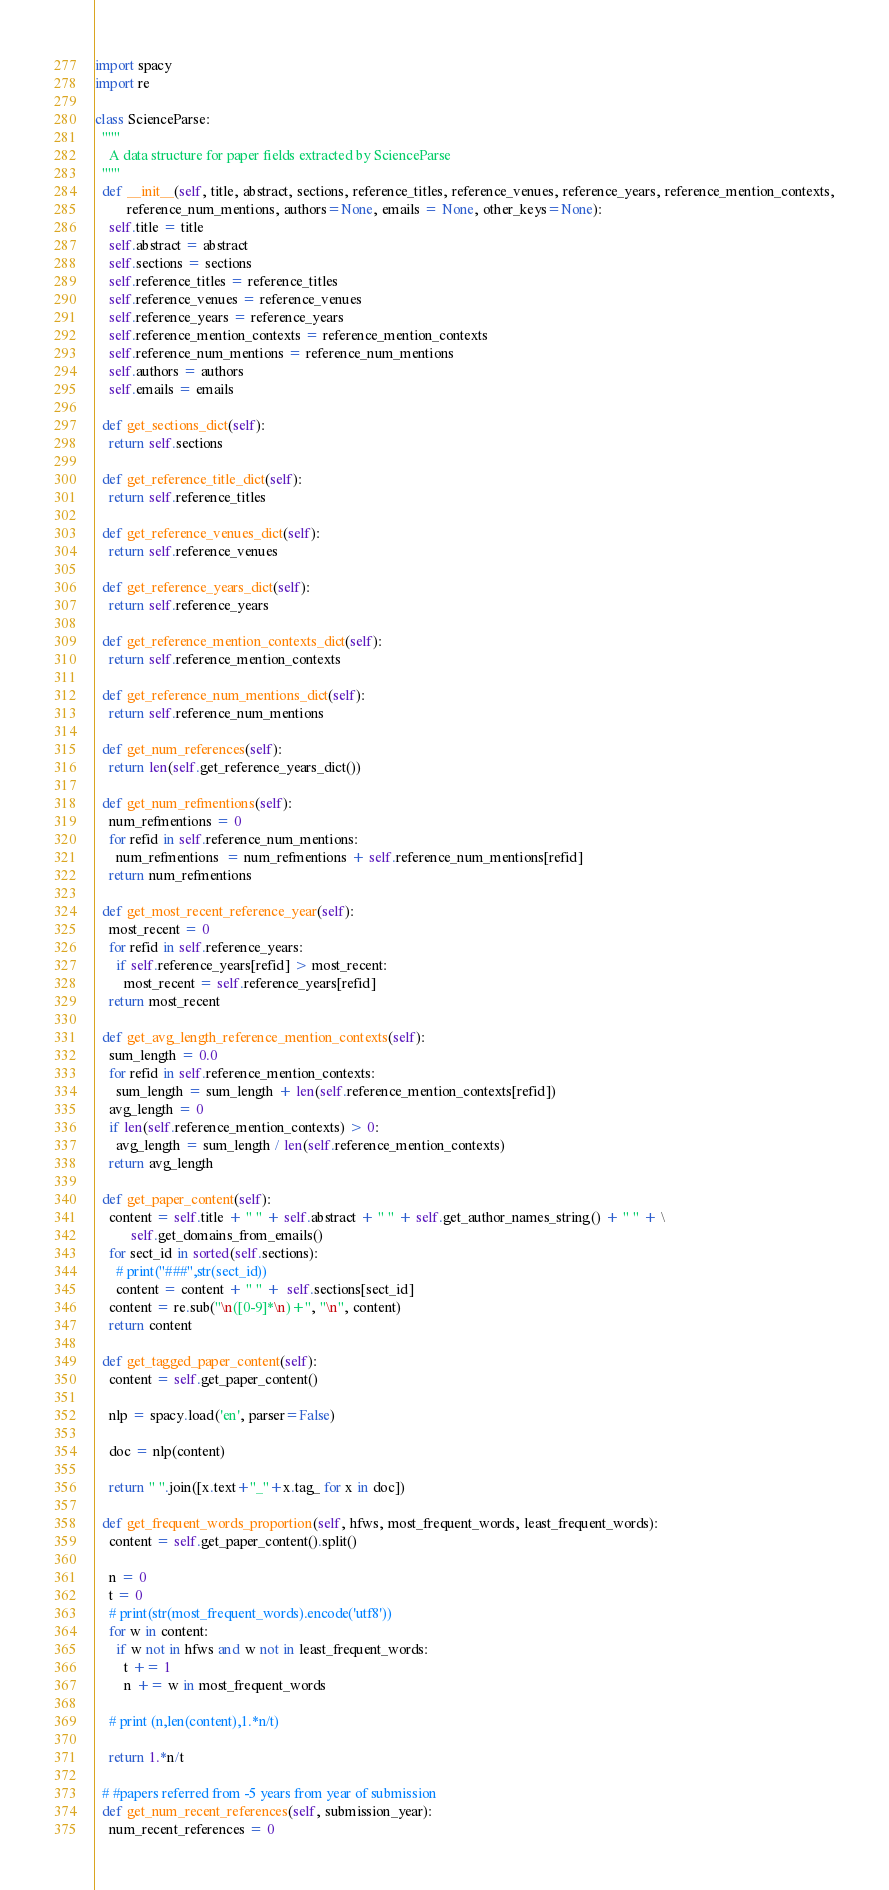Convert code to text. <code><loc_0><loc_0><loc_500><loc_500><_Python_>import spacy
import re

class ScienceParse:
  """
    A data structure for paper fields extracted by ScienceParse
  """
  def __init__(self, title, abstract, sections, reference_titles, reference_venues, reference_years, reference_mention_contexts,
         reference_num_mentions, authors=None, emails = None, other_keys=None):
    self.title = title
    self.abstract = abstract
    self.sections = sections
    self.reference_titles = reference_titles
    self.reference_venues = reference_venues
    self.reference_years = reference_years
    self.reference_mention_contexts = reference_mention_contexts
    self.reference_num_mentions = reference_num_mentions
    self.authors = authors
    self.emails = emails

  def get_sections_dict(self):
    return self.sections

  def get_reference_title_dict(self):
    return self.reference_titles

  def get_reference_venues_dict(self):
    return self.reference_venues

  def get_reference_years_dict(self):
    return self.reference_years

  def get_reference_mention_contexts_dict(self):
    return self.reference_mention_contexts

  def get_reference_num_mentions_dict(self):
    return self.reference_num_mentions

  def get_num_references(self):
    return len(self.get_reference_years_dict())

  def get_num_refmentions(self):
    num_refmentions = 0
    for refid in self.reference_num_mentions:
      num_refmentions  = num_refmentions + self.reference_num_mentions[refid]
    return num_refmentions

  def get_most_recent_reference_year(self):
    most_recent = 0
    for refid in self.reference_years:
      if self.reference_years[refid] > most_recent:
        most_recent = self.reference_years[refid]
    return most_recent

  def get_avg_length_reference_mention_contexts(self):
    sum_length = 0.0
    for refid in self.reference_mention_contexts:
      sum_length = sum_length + len(self.reference_mention_contexts[refid])
    avg_length = 0
    if len(self.reference_mention_contexts) > 0:
      avg_length = sum_length / len(self.reference_mention_contexts)
    return avg_length

  def get_paper_content(self):
    content = self.title + " " + self.abstract + " " + self.get_author_names_string() + " " + \
          self.get_domains_from_emails()
    for sect_id in sorted(self.sections):
      # print("###",str(sect_id))
      content = content + " " +  self.sections[sect_id]
    content = re.sub("\n([0-9]*\n)+", "\n", content)
    return content

  def get_tagged_paper_content(self):
    content = self.get_paper_content()

    nlp = spacy.load('en', parser=False)

    doc = nlp(content)

    return " ".join([x.text+"_"+x.tag_ for x in doc])

  def get_frequent_words_proportion(self, hfws, most_frequent_words, least_frequent_words):
    content = self.get_paper_content().split()

    n = 0
    t = 0
    # print(str(most_frequent_words).encode('utf8'))
    for w in content:
      if w not in hfws and w not in least_frequent_words:
        t += 1
        n += w in most_frequent_words

    # print (n,len(content),1.*n/t)

    return 1.*n/t

  # #papers referred from -5 years from year of submission
  def get_num_recent_references(self, submission_year):
    num_recent_references = 0</code> 